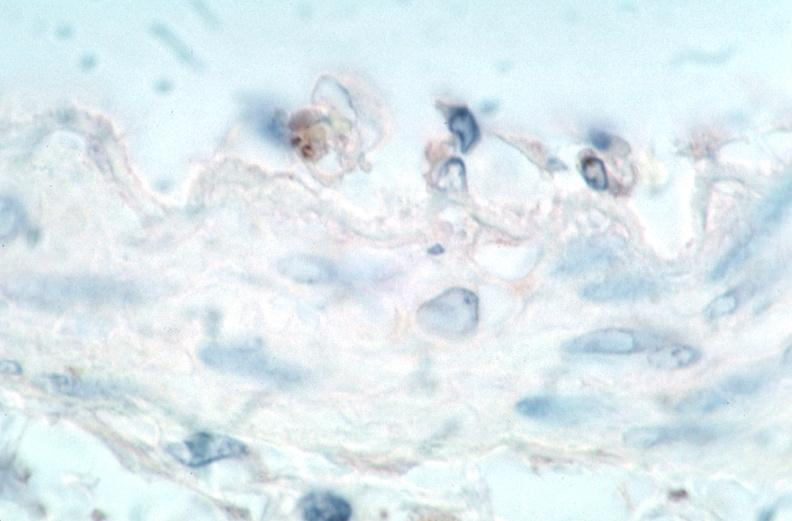what is vasculitis , rocky mountain spotted?
Answer the question using a single word or phrase. Fever immunoperoxidase staining vessels for rickettsia rickettsii 